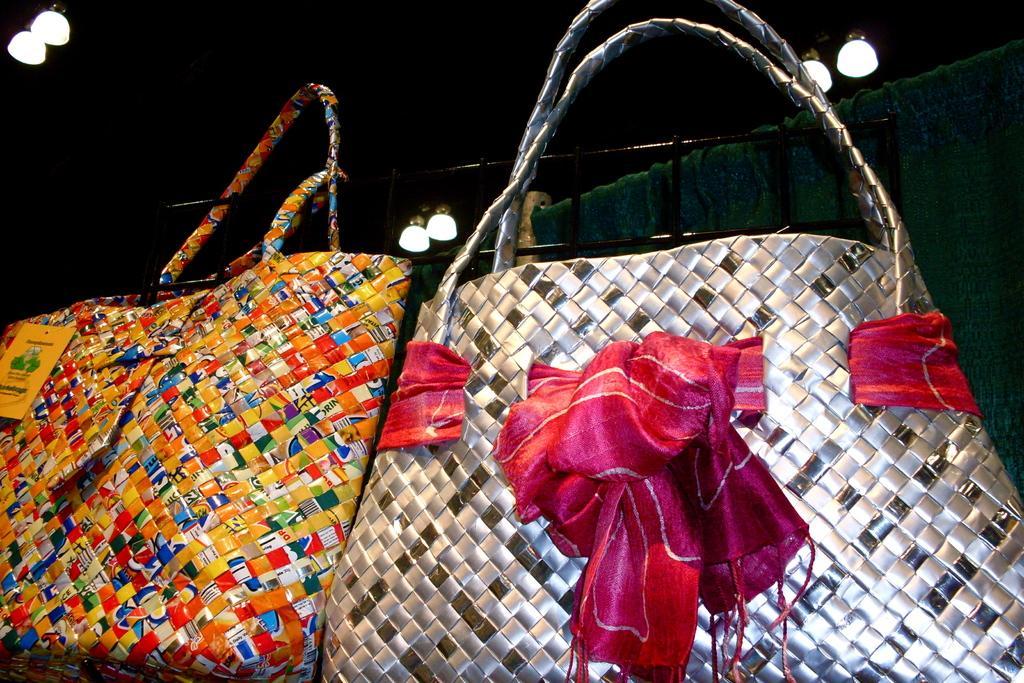Could you give a brief overview of what you see in this image? In this image there are two bags. One is in silver with ribbon around it and the other is multicolored. There are some lights on to the roof. 